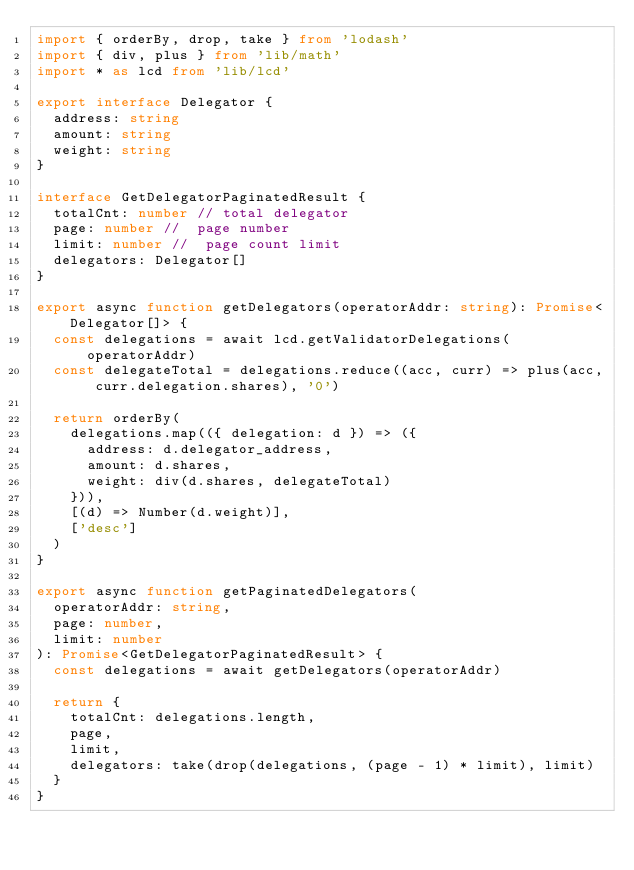Convert code to text. <code><loc_0><loc_0><loc_500><loc_500><_TypeScript_>import { orderBy, drop, take } from 'lodash'
import { div, plus } from 'lib/math'
import * as lcd from 'lib/lcd'

export interface Delegator {
  address: string
  amount: string
  weight: string
}

interface GetDelegatorPaginatedResult {
  totalCnt: number // total delegator
  page: number //  page number
  limit: number //  page count limit
  delegators: Delegator[]
}

export async function getDelegators(operatorAddr: string): Promise<Delegator[]> {
  const delegations = await lcd.getValidatorDelegations(operatorAddr)
  const delegateTotal = delegations.reduce((acc, curr) => plus(acc, curr.delegation.shares), '0')

  return orderBy(
    delegations.map(({ delegation: d }) => ({
      address: d.delegator_address,
      amount: d.shares,
      weight: div(d.shares, delegateTotal)
    })),
    [(d) => Number(d.weight)],
    ['desc']
  )
}

export async function getPaginatedDelegators(
  operatorAddr: string,
  page: number,
  limit: number
): Promise<GetDelegatorPaginatedResult> {
  const delegations = await getDelegators(operatorAddr)

  return {
    totalCnt: delegations.length,
    page,
    limit,
    delegators: take(drop(delegations, (page - 1) * limit), limit)
  }
}
</code> 